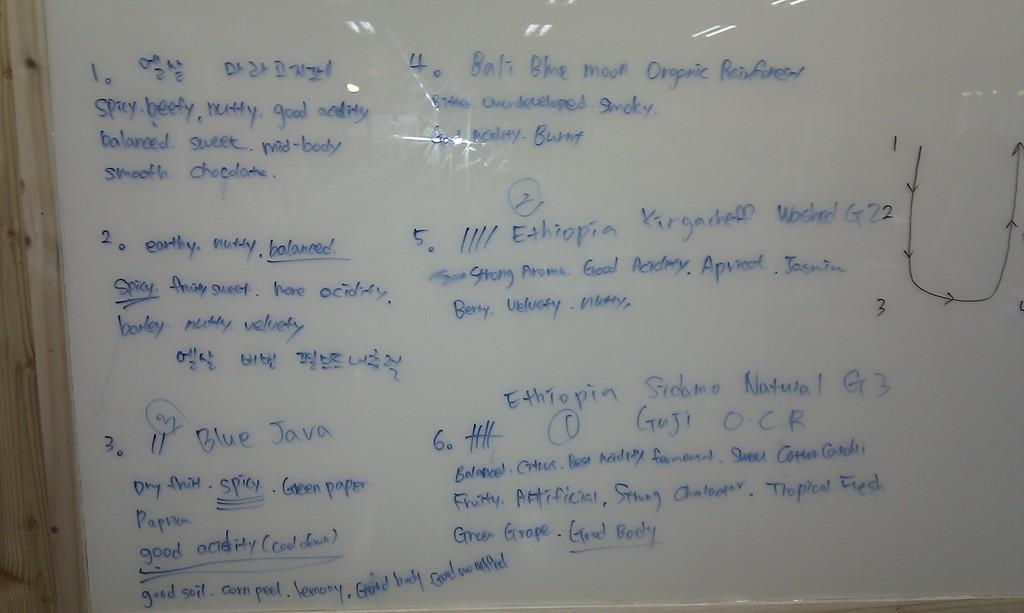<image>
Write a terse but informative summary of the picture. A whiteboard with blue writing describes a coffee as spicy, beefy and nutty. 